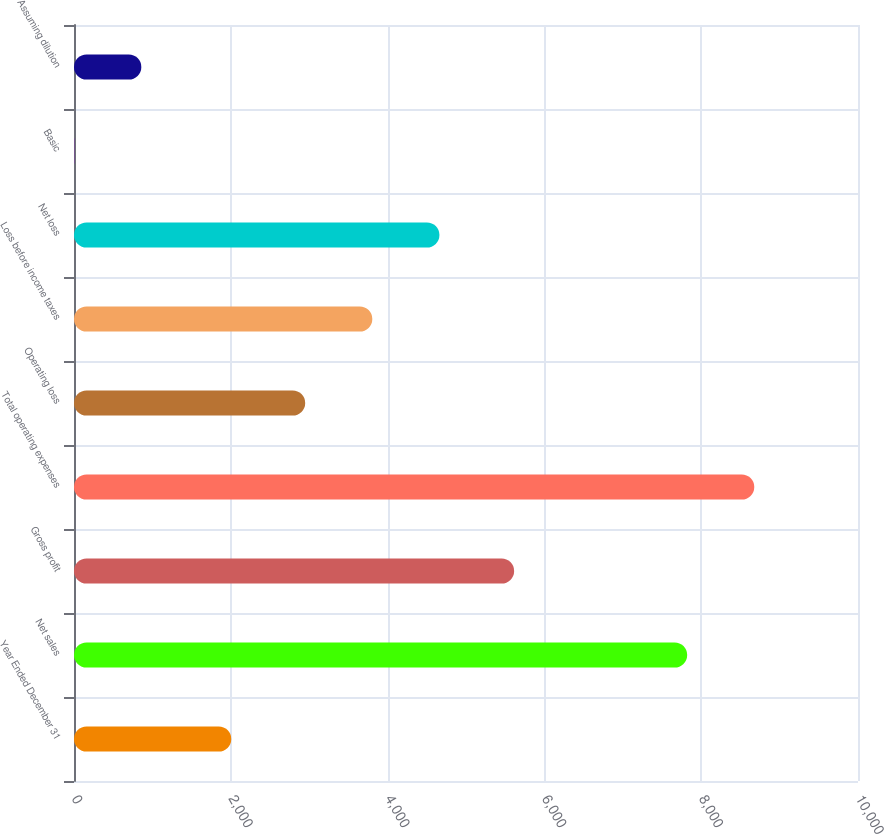Convert chart to OTSL. <chart><loc_0><loc_0><loc_500><loc_500><bar_chart><fcel>Year Ended December 31<fcel>Net sales<fcel>Gross profit<fcel>Total operating expenses<fcel>Operating loss<fcel>Loss before income taxes<fcel>Net loss<fcel>Basic<fcel>Assuming dilution<nl><fcel>2006<fcel>7821<fcel>5614<fcel>8677.02<fcel>2949<fcel>3805.02<fcel>4661.04<fcel>2.81<fcel>858.83<nl></chart> 